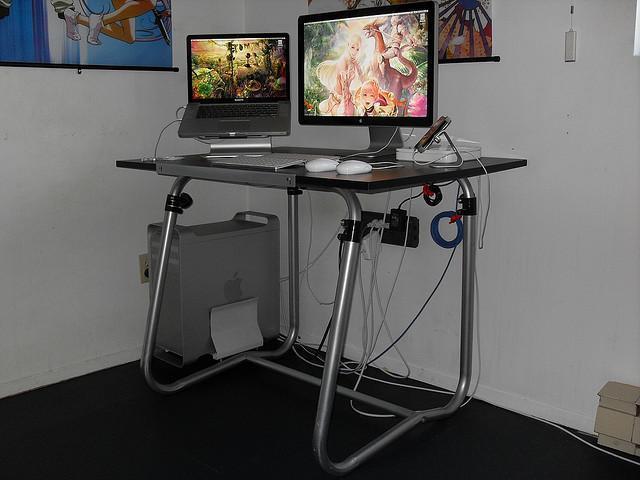How many girls are there?
Give a very brief answer. 0. 